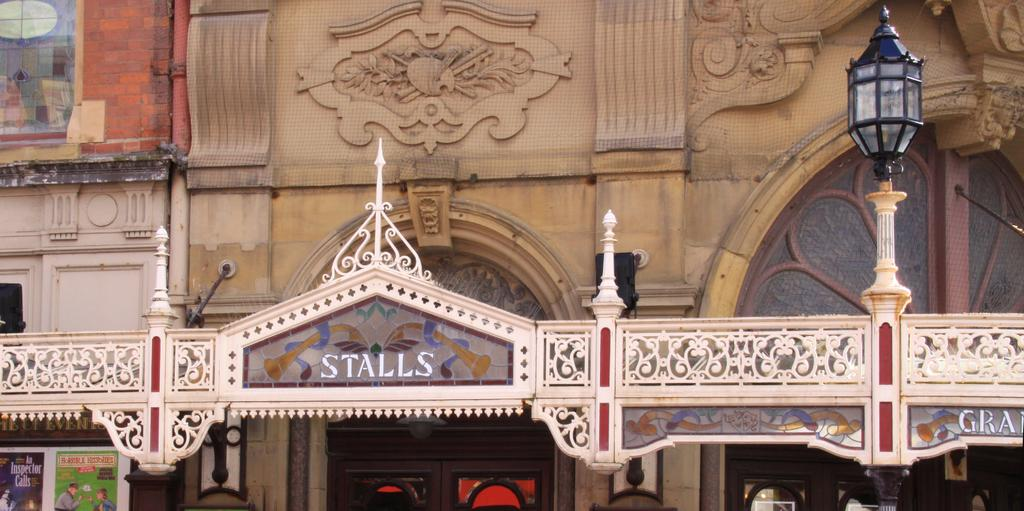What structure is the main subject of the image? There is a building in the image. What is located to the right of the building? There is a light pole to the right of the building. What can be seen on the surface of the building? There are boards visible on the building. What feature allows light to enter the building? There are windows visible on the building. What type of music is being played by the daughter in the image? There is no mention of a daughter or music in the image; it only describes a building, a light pole, boards, and windows. 